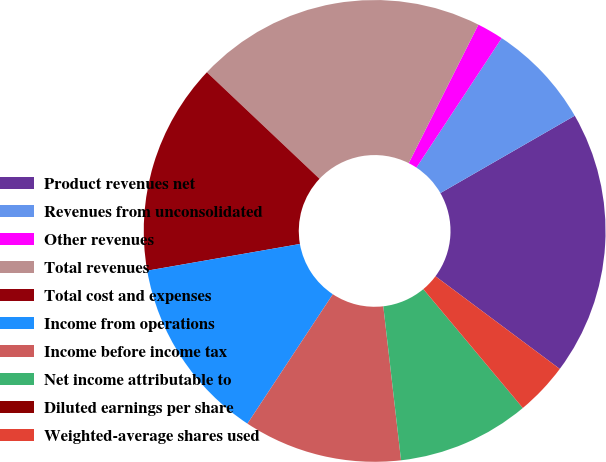Convert chart. <chart><loc_0><loc_0><loc_500><loc_500><pie_chart><fcel>Product revenues net<fcel>Revenues from unconsolidated<fcel>Other revenues<fcel>Total revenues<fcel>Total cost and expenses<fcel>Income from operations<fcel>Income before income tax<fcel>Net income attributable to<fcel>Diluted earnings per share<fcel>Weighted-average shares used<nl><fcel>18.51%<fcel>7.41%<fcel>1.86%<fcel>20.36%<fcel>14.81%<fcel>12.96%<fcel>11.11%<fcel>9.26%<fcel>0.01%<fcel>3.71%<nl></chart> 